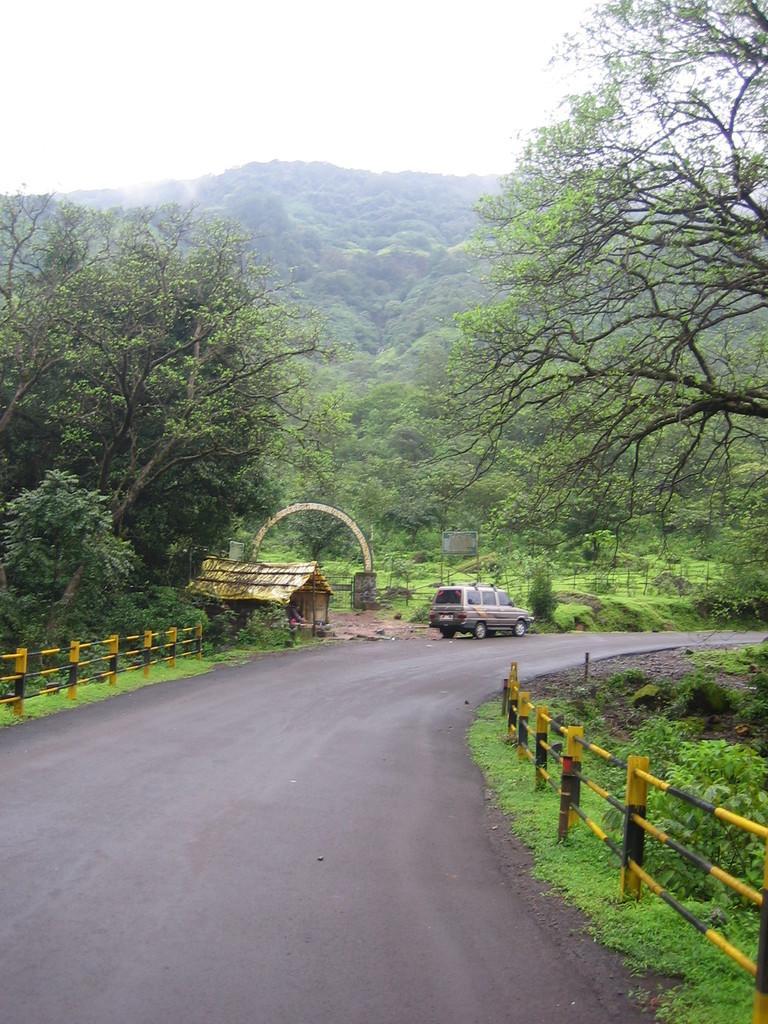Can you describe this image briefly? In this image I can see a vehicle on the road. On the left and right side, I can see the grass. In the background, I can see the trees. 